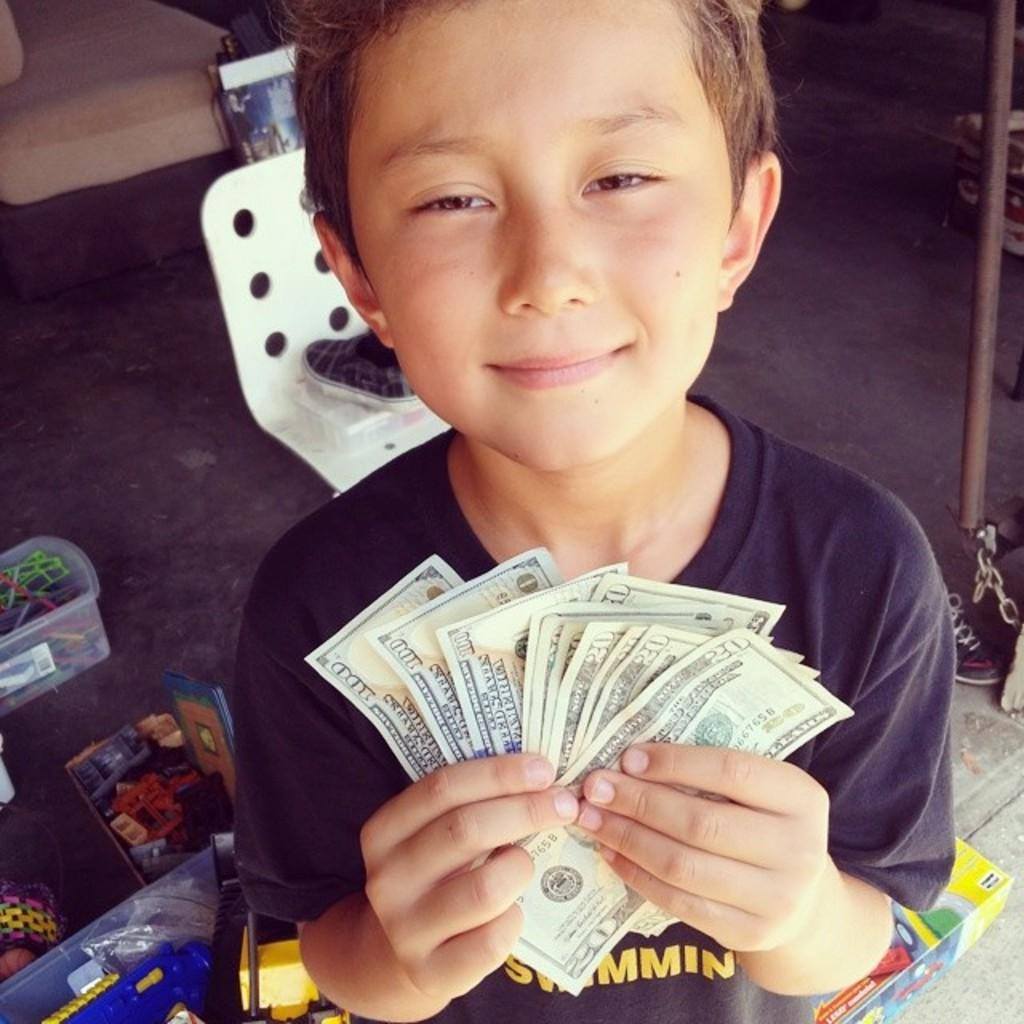What is the boy in the image doing? The boy is standing in the image and holding currency notes. What can be seen in the background of the image? There are toys and a chair in the background of the image. What is the chair placed on? The chair is on a carpet. What type of cast can be seen on the boy's arm in the image? There is no cast visible on the boy's arm in the image. What cable is connected to the toys in the background? There is no cable connected to the toys in the image. 